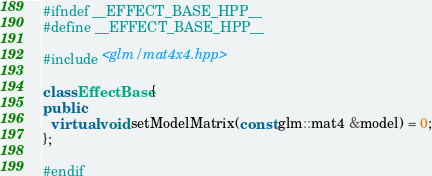<code> <loc_0><loc_0><loc_500><loc_500><_C++_>#ifndef __EFFECT_BASE_HPP__
#define __EFFECT_BASE_HPP__

#include <glm/mat4x4.hpp>

class EffectBase {
public:
  virtual void setModelMatrix(const glm::mat4 &model) = 0;
};

#endif
</code> 